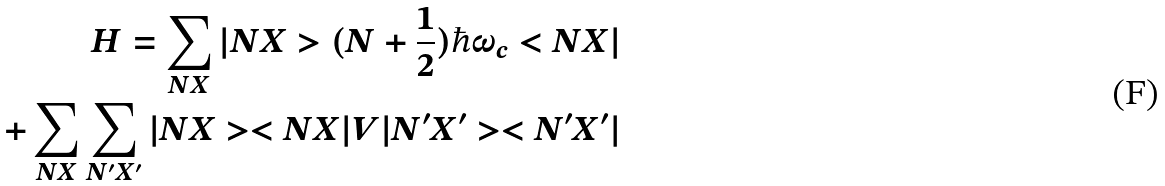<formula> <loc_0><loc_0><loc_500><loc_500>H = \sum _ { N X } | N X > ( N + \frac { 1 } { 2 } ) \hbar { \omega } _ { c } < N X | \\ + \sum _ { N X } \sum _ { N ^ { \prime } X ^ { \prime } } | N X > < N X | V | N ^ { \prime } X ^ { \prime } > < N ^ { \prime } X ^ { \prime } |</formula> 